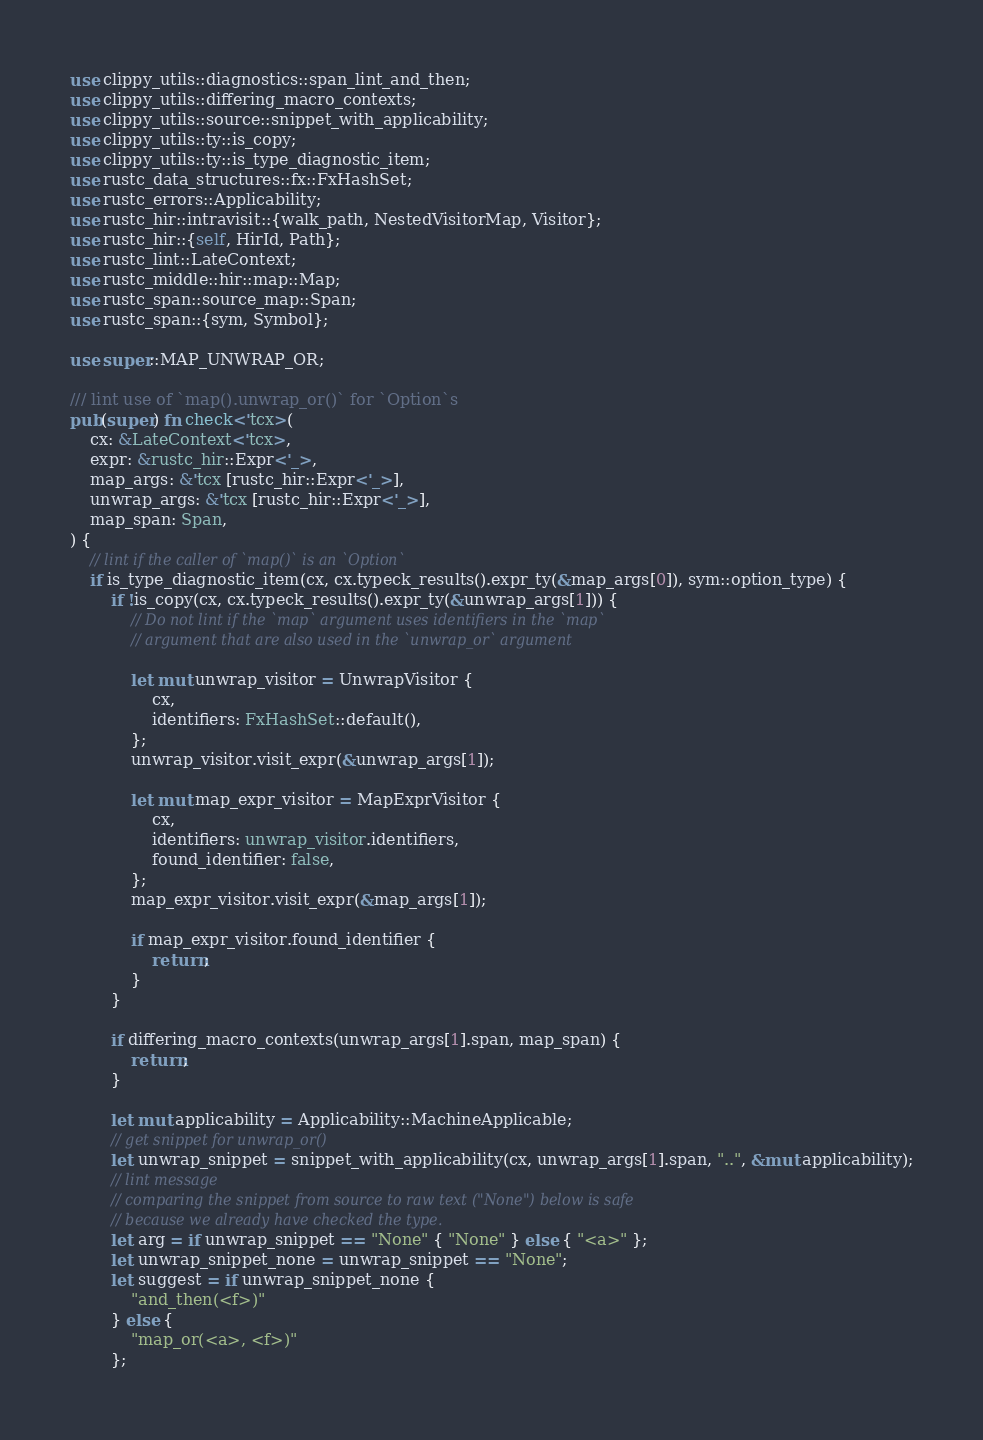<code> <loc_0><loc_0><loc_500><loc_500><_Rust_>use clippy_utils::diagnostics::span_lint_and_then;
use clippy_utils::differing_macro_contexts;
use clippy_utils::source::snippet_with_applicability;
use clippy_utils::ty::is_copy;
use clippy_utils::ty::is_type_diagnostic_item;
use rustc_data_structures::fx::FxHashSet;
use rustc_errors::Applicability;
use rustc_hir::intravisit::{walk_path, NestedVisitorMap, Visitor};
use rustc_hir::{self, HirId, Path};
use rustc_lint::LateContext;
use rustc_middle::hir::map::Map;
use rustc_span::source_map::Span;
use rustc_span::{sym, Symbol};

use super::MAP_UNWRAP_OR;

/// lint use of `map().unwrap_or()` for `Option`s
pub(super) fn check<'tcx>(
    cx: &LateContext<'tcx>,
    expr: &rustc_hir::Expr<'_>,
    map_args: &'tcx [rustc_hir::Expr<'_>],
    unwrap_args: &'tcx [rustc_hir::Expr<'_>],
    map_span: Span,
) {
    // lint if the caller of `map()` is an `Option`
    if is_type_diagnostic_item(cx, cx.typeck_results().expr_ty(&map_args[0]), sym::option_type) {
        if !is_copy(cx, cx.typeck_results().expr_ty(&unwrap_args[1])) {
            // Do not lint if the `map` argument uses identifiers in the `map`
            // argument that are also used in the `unwrap_or` argument

            let mut unwrap_visitor = UnwrapVisitor {
                cx,
                identifiers: FxHashSet::default(),
            };
            unwrap_visitor.visit_expr(&unwrap_args[1]);

            let mut map_expr_visitor = MapExprVisitor {
                cx,
                identifiers: unwrap_visitor.identifiers,
                found_identifier: false,
            };
            map_expr_visitor.visit_expr(&map_args[1]);

            if map_expr_visitor.found_identifier {
                return;
            }
        }

        if differing_macro_contexts(unwrap_args[1].span, map_span) {
            return;
        }

        let mut applicability = Applicability::MachineApplicable;
        // get snippet for unwrap_or()
        let unwrap_snippet = snippet_with_applicability(cx, unwrap_args[1].span, "..", &mut applicability);
        // lint message
        // comparing the snippet from source to raw text ("None") below is safe
        // because we already have checked the type.
        let arg = if unwrap_snippet == "None" { "None" } else { "<a>" };
        let unwrap_snippet_none = unwrap_snippet == "None";
        let suggest = if unwrap_snippet_none {
            "and_then(<f>)"
        } else {
            "map_or(<a>, <f>)"
        };</code> 